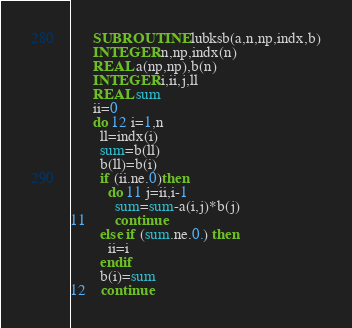<code> <loc_0><loc_0><loc_500><loc_500><_FORTRAN_>      SUBROUTINE lubksb(a,n,np,indx,b)
      INTEGER n,np,indx(n)
      REAL a(np,np),b(n)
      INTEGER i,ii,j,ll
      REAL sum
      ii=0
      do 12 i=1,n
        ll=indx(i)
        sum=b(ll)
        b(ll)=b(i)
        if (ii.ne.0)then
          do 11 j=ii,i-1
            sum=sum-a(i,j)*b(j)
11        continue
        else if (sum.ne.0.) then
          ii=i
        endif
        b(i)=sum
12    continue</code> 